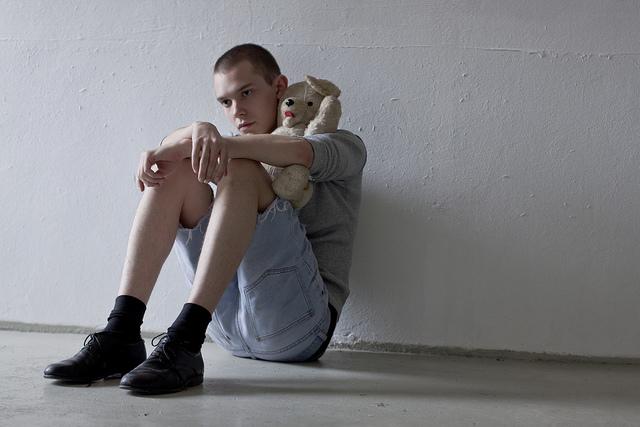Is this man on a vacation?
Write a very short answer. No. Is this a common posture for travelers?
Quick response, please. No. Is the boy smiling?
Concise answer only. No. Does the boy like teddy bears?
Give a very brief answer. Yes. How many people are in this picture?
Short answer required. 1. Is the boy under the age of 4?
Keep it brief. No. How many people are shown?
Keep it brief. 1. 